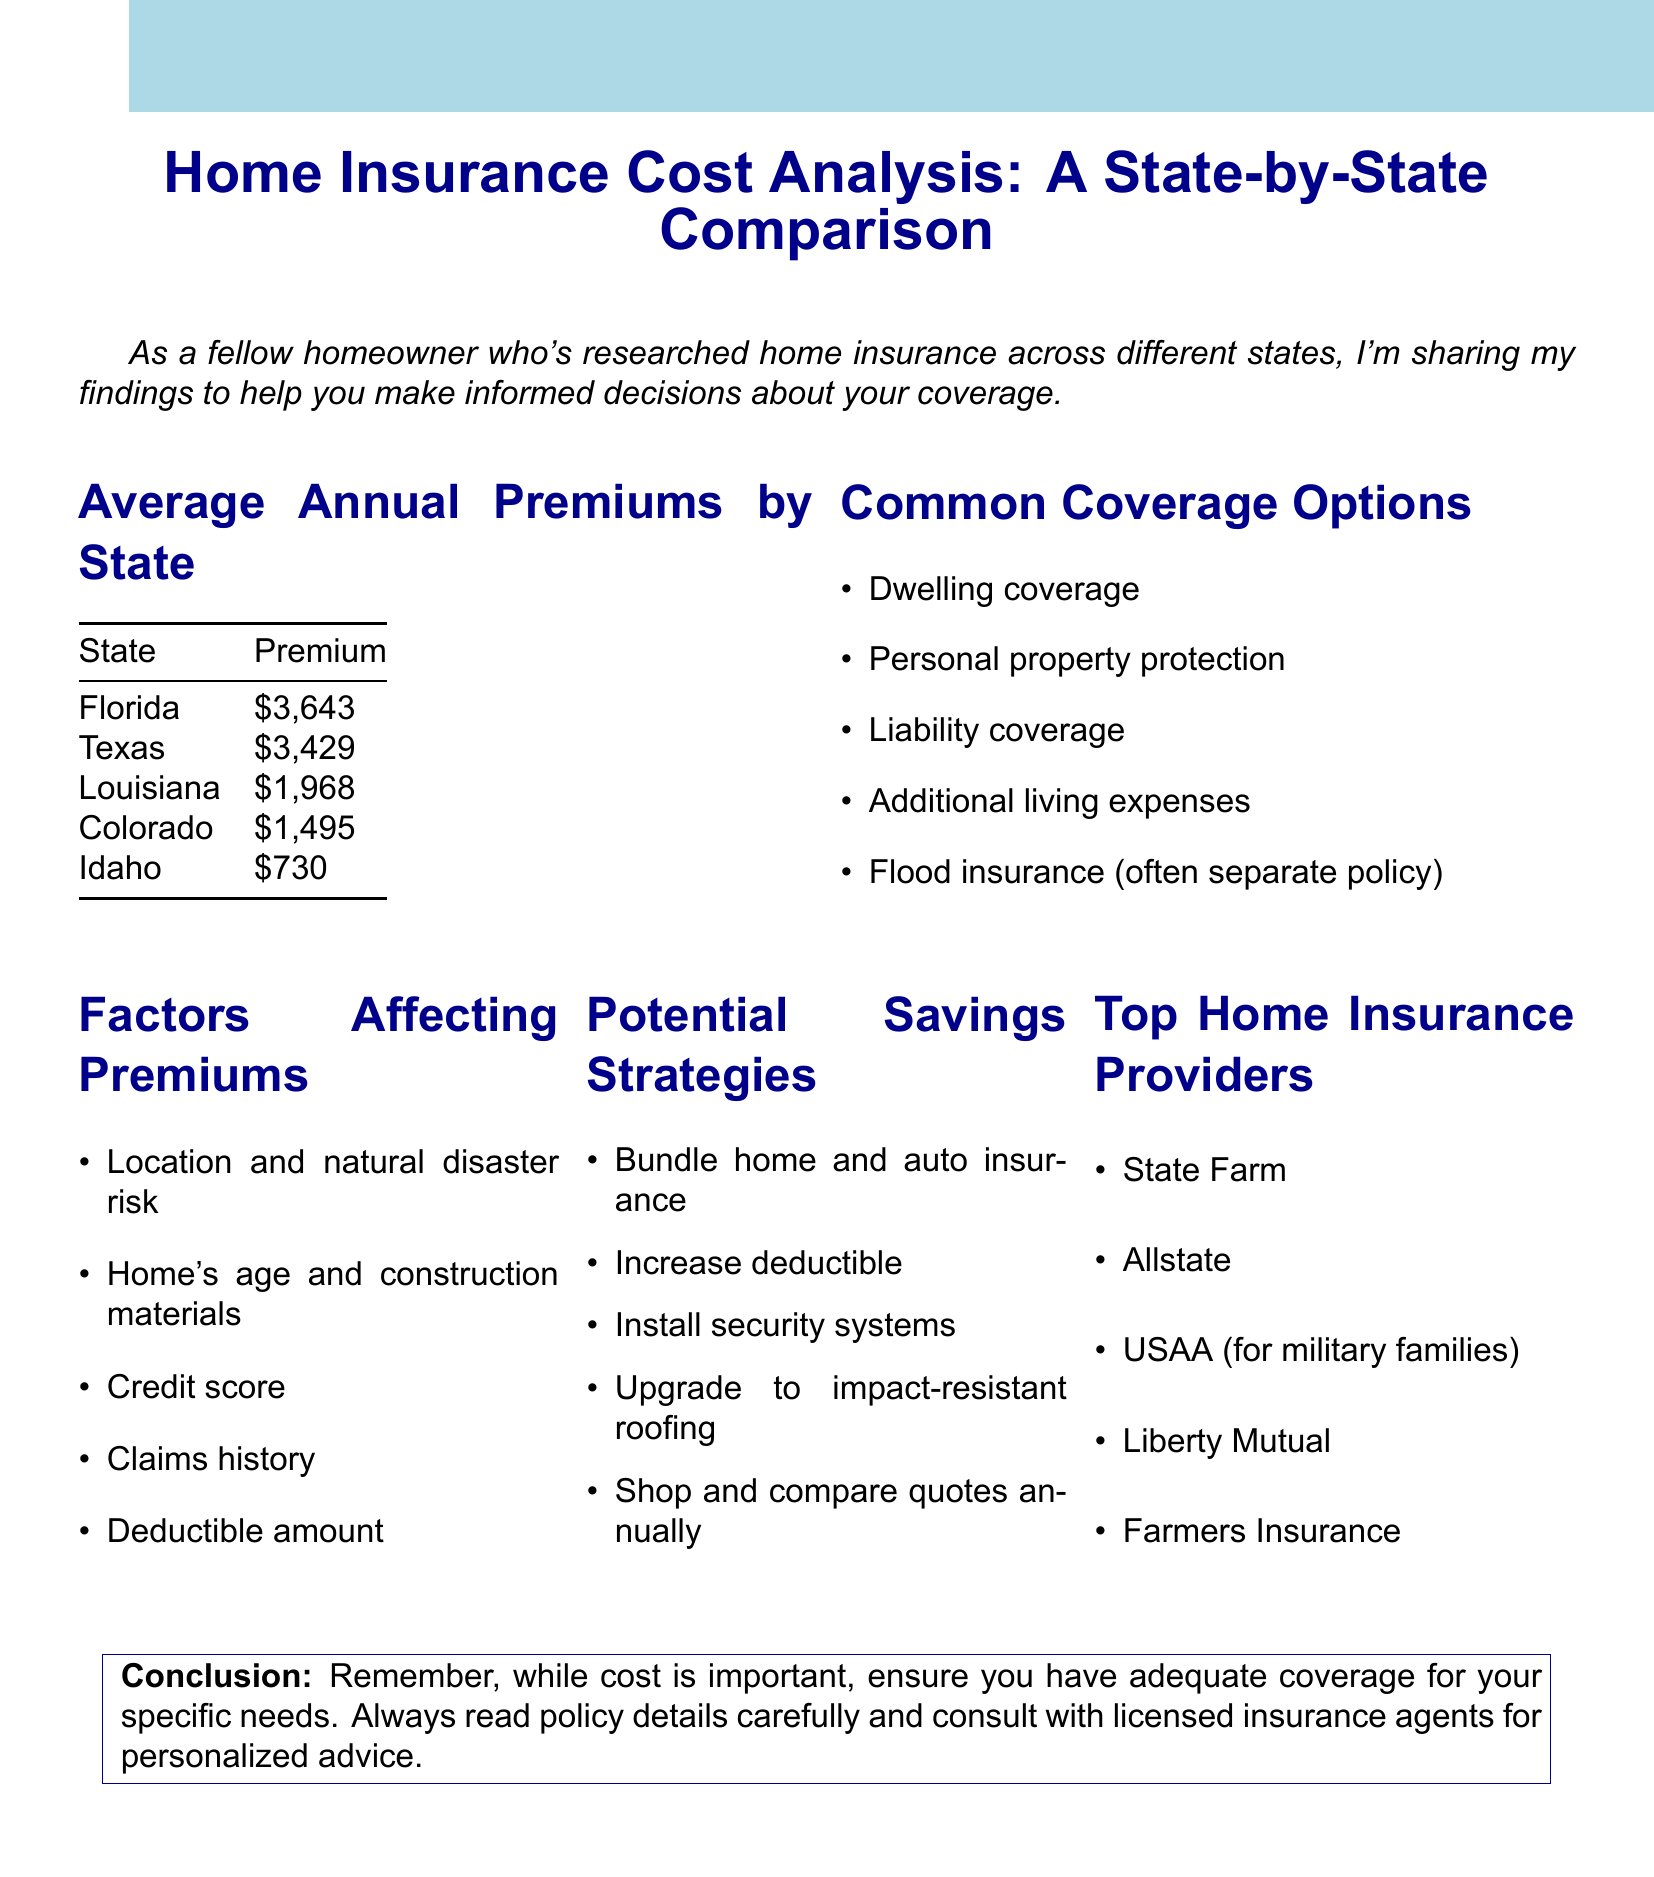What is the average annual premium in Florida? The average annual premium for Florida is listed in the document under "Average Annual Premiums by State".
Answer: $3,643 Which coverage option is often a separate policy? The document specifies that flood insurance is typically a separate policy under "Common Coverage Options".
Answer: Flood insurance What is a factor affecting premiums related to natural disasters? The document mentions "Location and natural disaster risk" as a factor affecting premiums under "Factors Affecting Premiums".
Answer: Location and natural disaster risk What is one potential savings strategy mentioned? The document lists various strategies for saving on premiums in "Potential Savings Strategies". One of them can be quoted directly.
Answer: Bundle home and auto insurance Which is a top home insurance provider? The document provides a list of top home insurance providers under the corresponding section.
Answer: State Farm What is the average annual premium in Idaho? The specific premium for Idaho is included in the "Average Annual Premiums by State" data.
Answer: $730 How many common coverage options are listed? The number of options is counted from the section titled "Common Coverage Options".
Answer: 5 Which condition can affect your insurance premium related to your financial behavior? The document mentions that "Credit score" is a factor affecting premiums under "Factors Affecting Premiums".
Answer: Credit score 